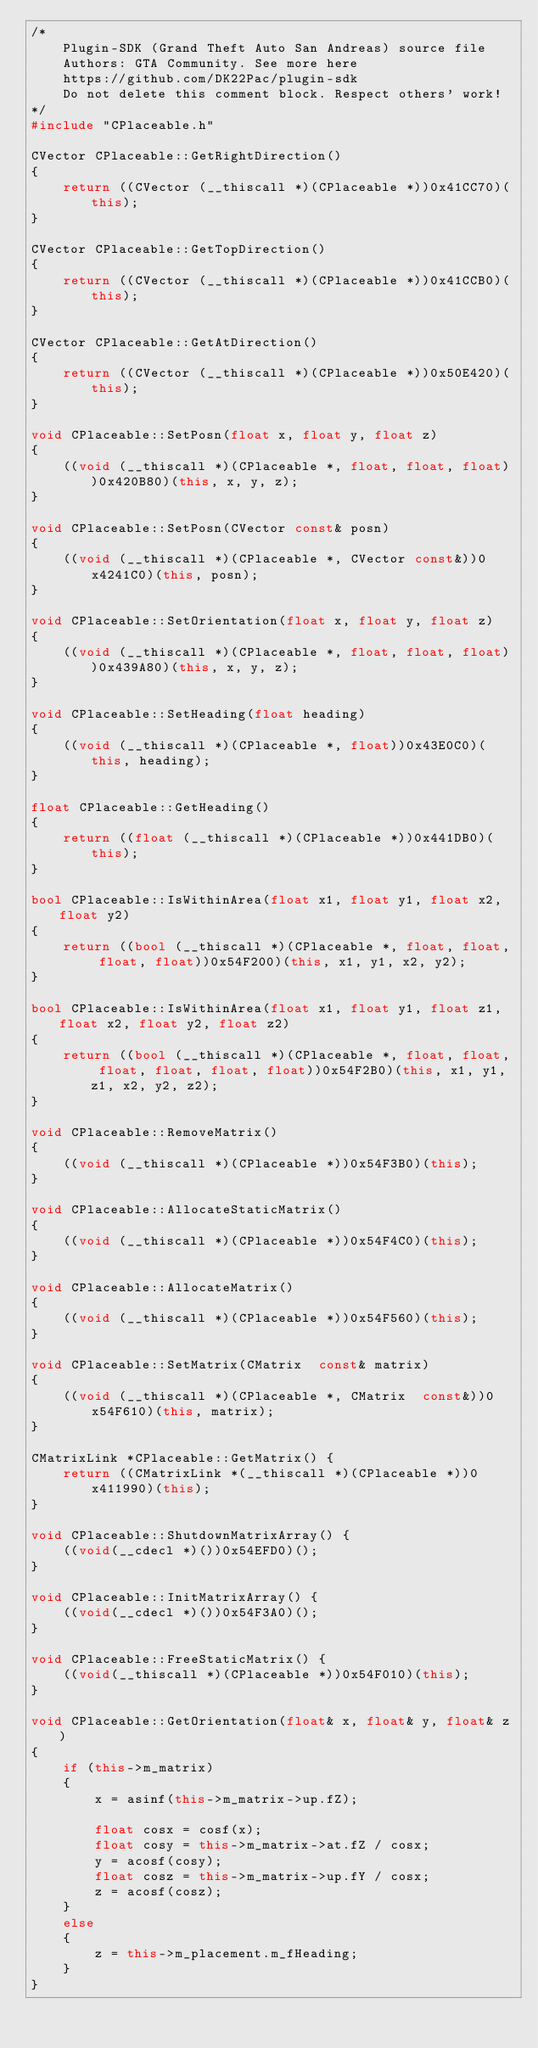Convert code to text. <code><loc_0><loc_0><loc_500><loc_500><_C++_>/*
    Plugin-SDK (Grand Theft Auto San Andreas) source file
    Authors: GTA Community. See more here
    https://github.com/DK22Pac/plugin-sdk
    Do not delete this comment block. Respect others' work!
*/
#include "CPlaceable.h"

CVector CPlaceable::GetRightDirection()
{
	return ((CVector (__thiscall *)(CPlaceable *))0x41CC70)(this);
}

CVector CPlaceable::GetTopDirection()
{
	return ((CVector (__thiscall *)(CPlaceable *))0x41CCB0)(this);
}

CVector CPlaceable::GetAtDirection()
{
	return ((CVector (__thiscall *)(CPlaceable *))0x50E420)(this);
}

void CPlaceable::SetPosn(float x, float y, float z)
{
	((void (__thiscall *)(CPlaceable *, float, float, float))0x420B80)(this, x, y, z);
}

void CPlaceable::SetPosn(CVector const& posn)
{
	((void (__thiscall *)(CPlaceable *, CVector const&))0x4241C0)(this, posn);
}

void CPlaceable::SetOrientation(float x, float y, float z)
{
	((void (__thiscall *)(CPlaceable *, float, float, float))0x439A80)(this, x, y, z);
}

void CPlaceable::SetHeading(float heading)
{
	((void (__thiscall *)(CPlaceable *, float))0x43E0C0)(this, heading);
}

float CPlaceable::GetHeading()
{
	return ((float (__thiscall *)(CPlaceable *))0x441DB0)(this);
}

bool CPlaceable::IsWithinArea(float x1, float y1, float x2, float y2)
{
	return ((bool (__thiscall *)(CPlaceable *, float, float, float, float))0x54F200)(this, x1, y1, x2, y2);
}

bool CPlaceable::IsWithinArea(float x1, float y1, float z1, float x2, float y2, float z2)
{
	return ((bool (__thiscall *)(CPlaceable *, float, float, float, float, float, float))0x54F2B0)(this, x1, y1, z1, x2, y2, z2);
}

void CPlaceable::RemoveMatrix()
{
	((void (__thiscall *)(CPlaceable *))0x54F3B0)(this);
}

void CPlaceable::AllocateStaticMatrix()
{
	((void (__thiscall *)(CPlaceable *))0x54F4C0)(this);
}

void CPlaceable::AllocateMatrix()
{
	((void (__thiscall *)(CPlaceable *))0x54F560)(this);
}

void CPlaceable::SetMatrix(CMatrix  const& matrix)
{
	((void (__thiscall *)(CPlaceable *, CMatrix  const&))0x54F610)(this, matrix);
}

CMatrixLink *CPlaceable::GetMatrix() {
    return ((CMatrixLink *(__thiscall *)(CPlaceable *))0x411990)(this);
}

void CPlaceable::ShutdownMatrixArray() {
    ((void(__cdecl *)())0x54EFD0)();
}

void CPlaceable::InitMatrixArray() {
    ((void(__cdecl *)())0x54F3A0)();
}

void CPlaceable::FreeStaticMatrix() {
    ((void(__thiscall *)(CPlaceable *))0x54F010)(this);
}

void CPlaceable::GetOrientation(float& x, float& y, float& z)
{
    if (this->m_matrix)
    {
        x = asinf(this->m_matrix->up.fZ);

        float cosx = cosf(x);
        float cosy = this->m_matrix->at.fZ / cosx;
        y = acosf(cosy);
        float cosz = this->m_matrix->up.fY / cosx;
        z = acosf(cosz);
    }
    else
    {
        z = this->m_placement.m_fHeading;
    }
}</code> 